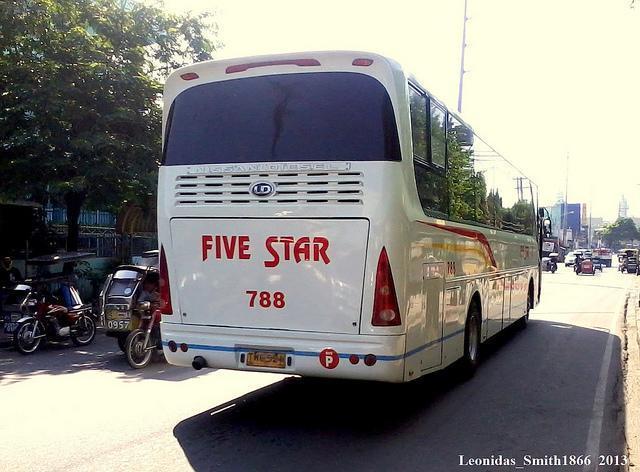How many motorcycles are there?
Give a very brief answer. 2. 